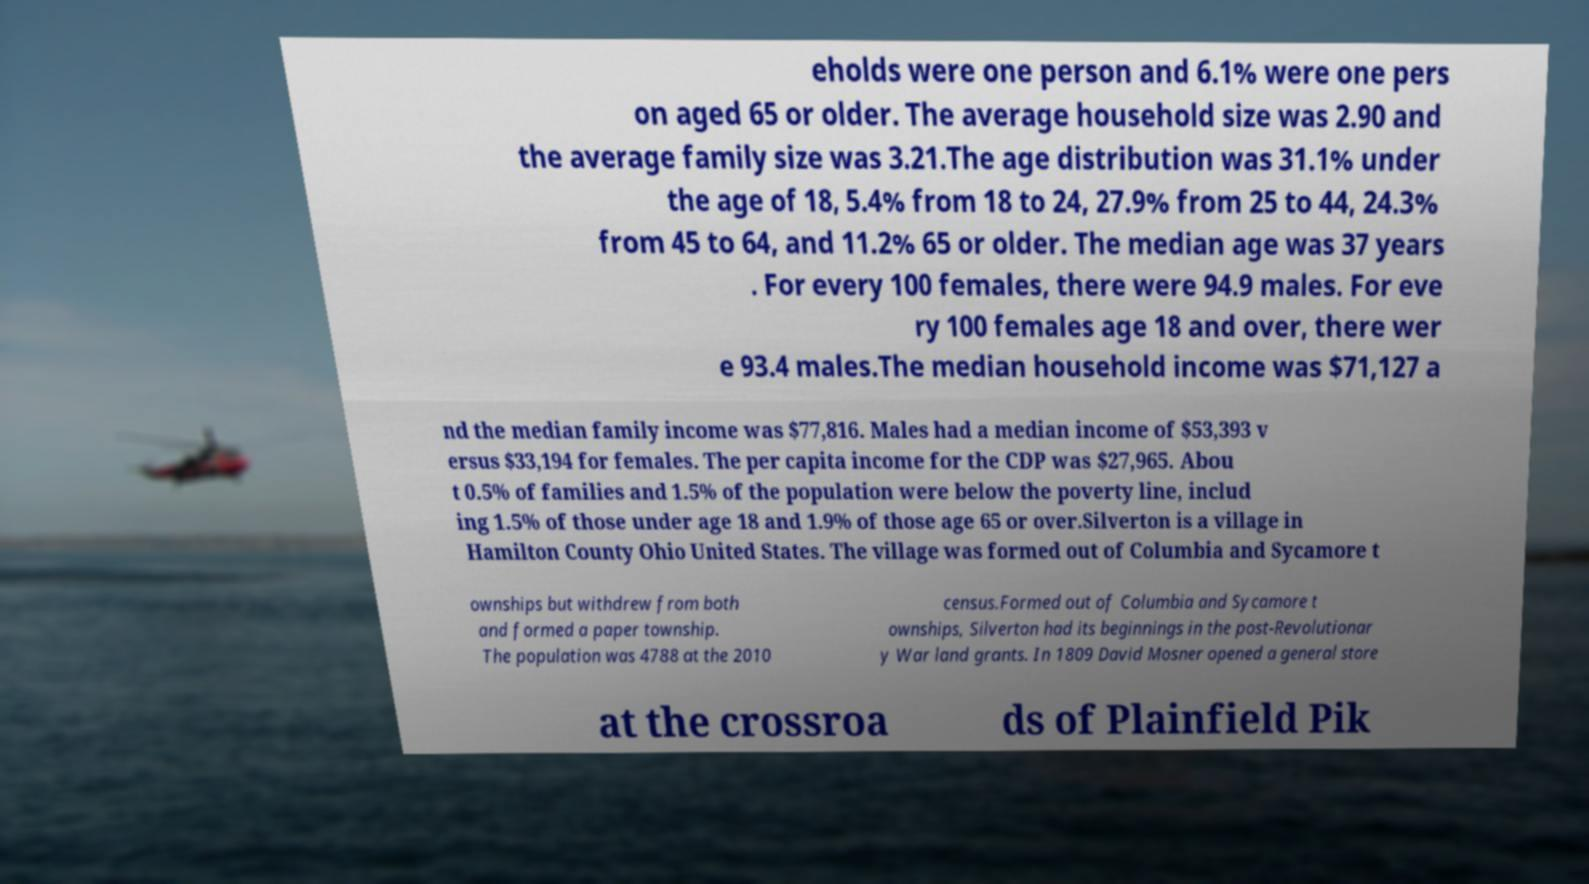For documentation purposes, I need the text within this image transcribed. Could you provide that? eholds were one person and 6.1% were one pers on aged 65 or older. The average household size was 2.90 and the average family size was 3.21.The age distribution was 31.1% under the age of 18, 5.4% from 18 to 24, 27.9% from 25 to 44, 24.3% from 45 to 64, and 11.2% 65 or older. The median age was 37 years . For every 100 females, there were 94.9 males. For eve ry 100 females age 18 and over, there wer e 93.4 males.The median household income was $71,127 a nd the median family income was $77,816. Males had a median income of $53,393 v ersus $33,194 for females. The per capita income for the CDP was $27,965. Abou t 0.5% of families and 1.5% of the population were below the poverty line, includ ing 1.5% of those under age 18 and 1.9% of those age 65 or over.Silverton is a village in Hamilton County Ohio United States. The village was formed out of Columbia and Sycamore t ownships but withdrew from both and formed a paper township. The population was 4788 at the 2010 census.Formed out of Columbia and Sycamore t ownships, Silverton had its beginnings in the post-Revolutionar y War land grants. In 1809 David Mosner opened a general store at the crossroa ds of Plainfield Pik 